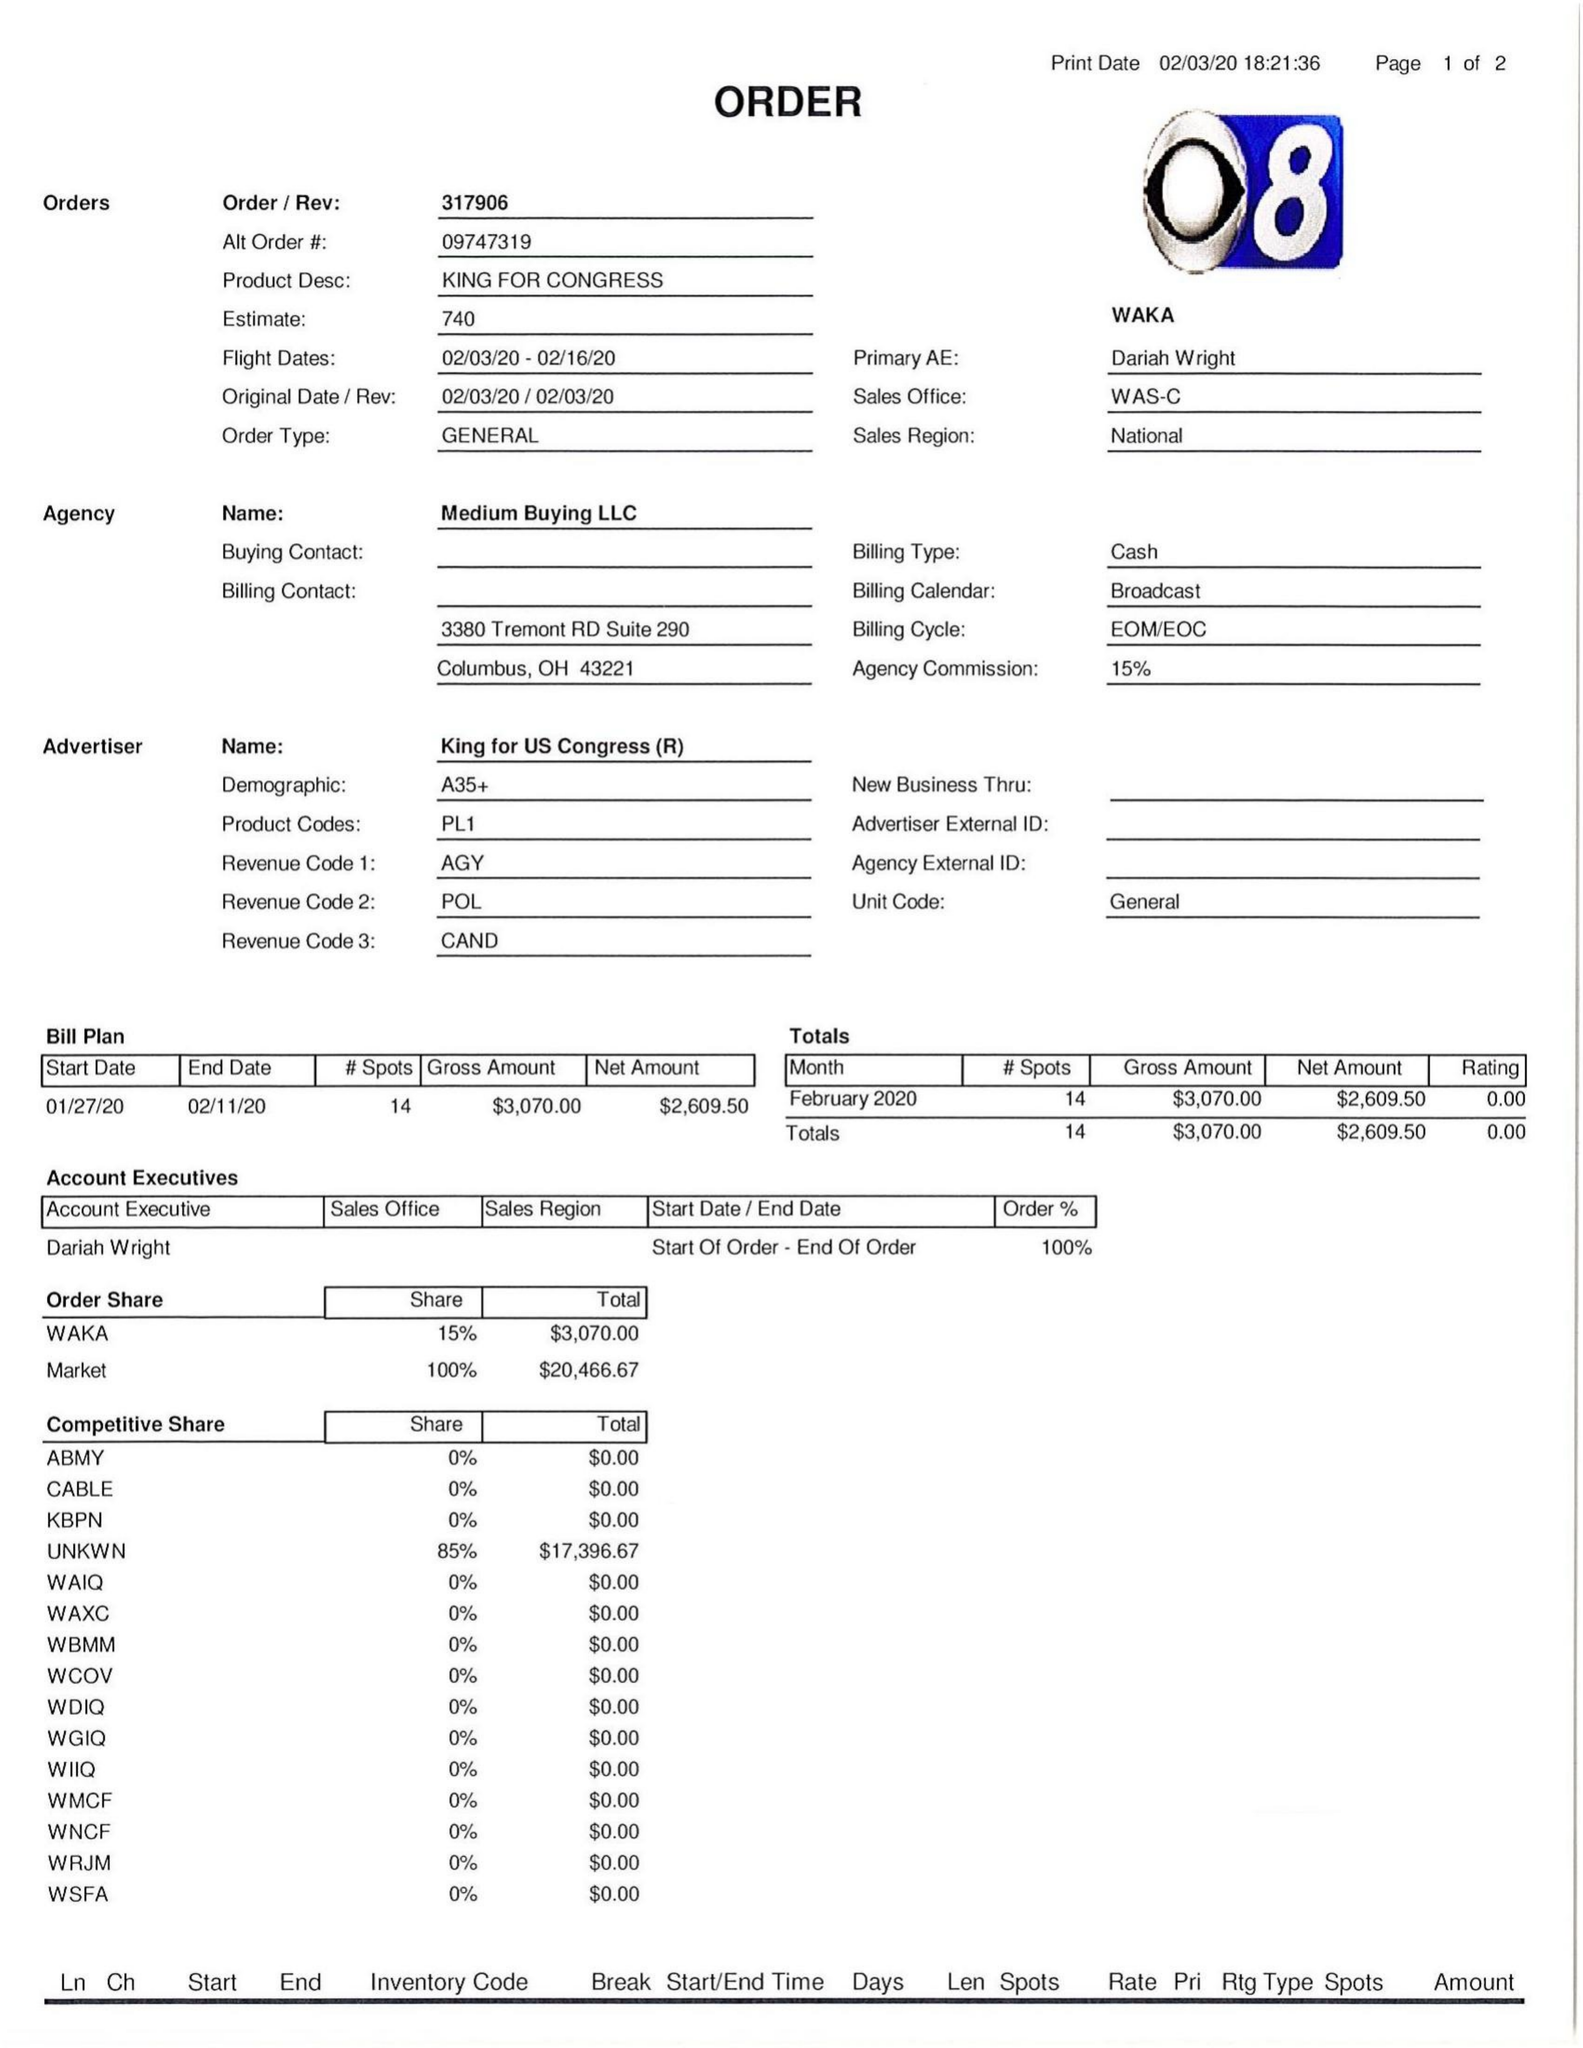What is the value for the gross_amount?
Answer the question using a single word or phrase. 3070.00 